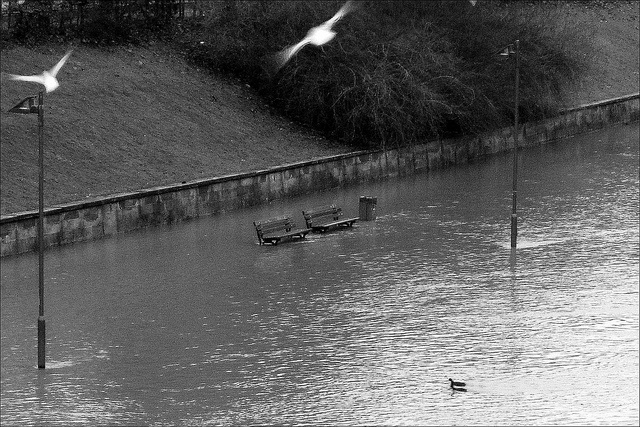Describe the objects in this image and their specific colors. I can see bird in black, lightgray, gray, and darkgray tones, bench in black, gray, and lightgray tones, bench in black, gray, darkgray, and lightgray tones, bird in black, lightgray, gray, and darkgray tones, and bird in black, darkgray, gray, and lightgray tones in this image. 